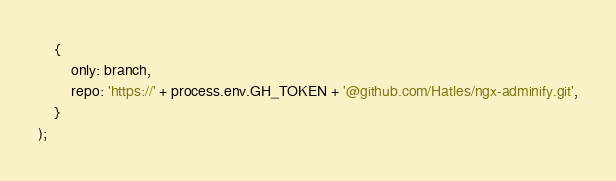<code> <loc_0><loc_0><loc_500><loc_500><_JavaScript_>    {
        only: branch,
        repo: 'https://' + process.env.GH_TOKEN + '@github.com/Hatles/ngx-adminify.git',
    }
);
</code> 